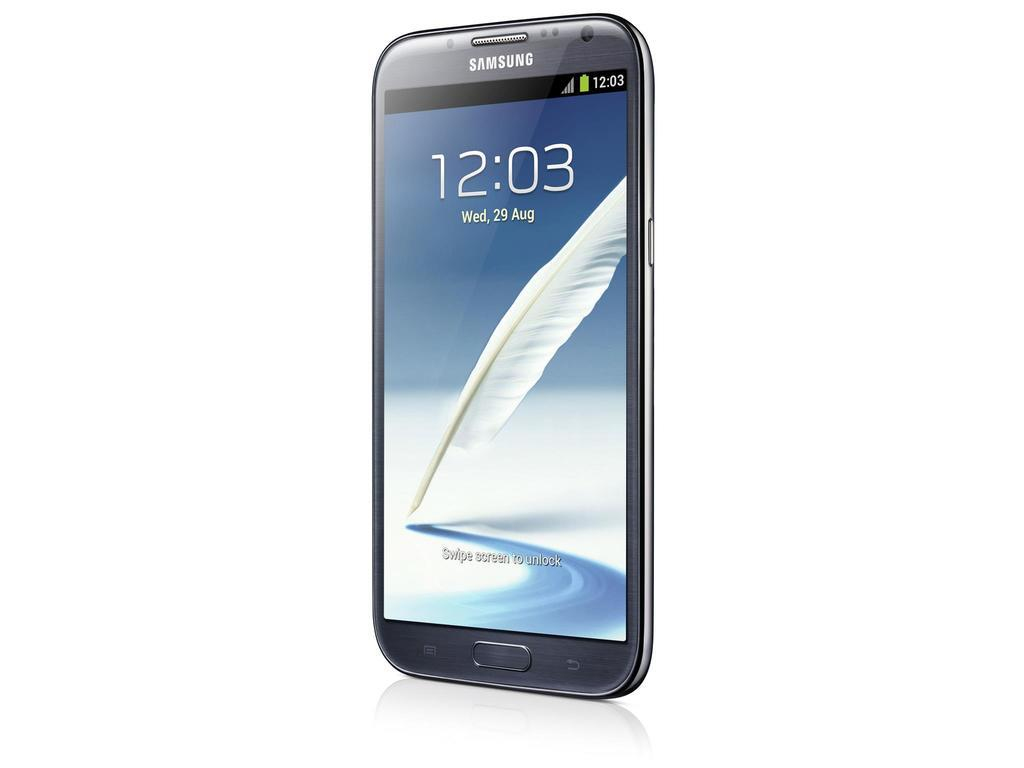Provide a one-sentence caption for the provided image. A samsung smartphone with the image of a feather on it's screen. 